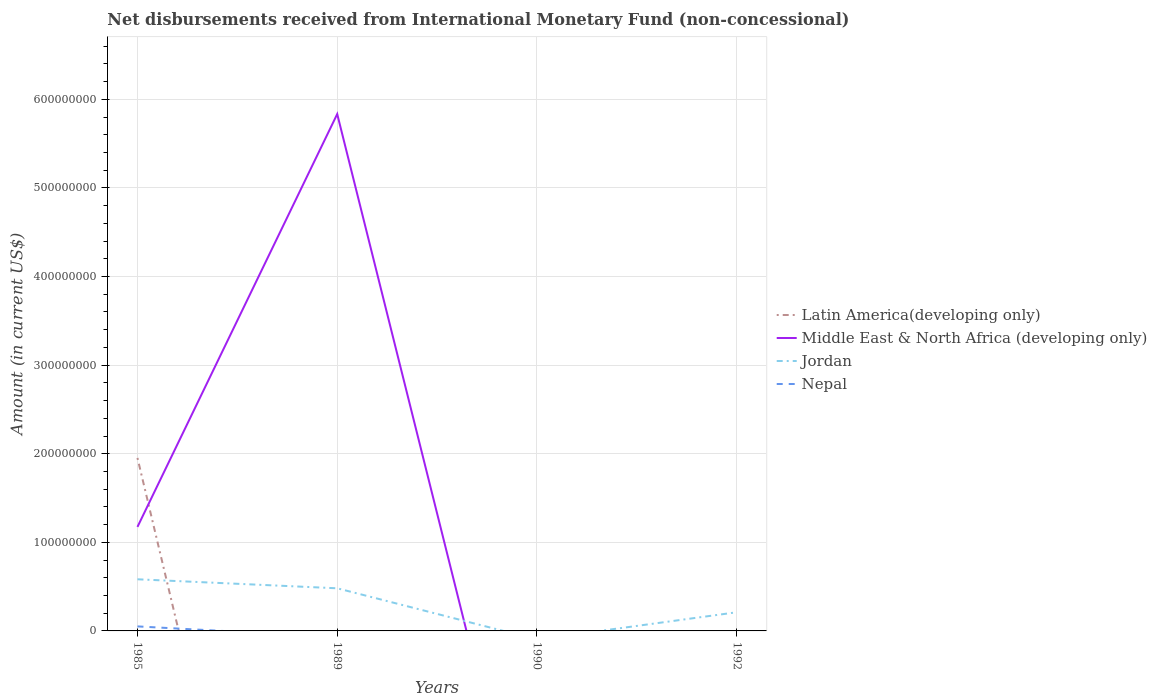How many different coloured lines are there?
Provide a succinct answer. 4. Does the line corresponding to Middle East & North Africa (developing only) intersect with the line corresponding to Jordan?
Keep it short and to the point. Yes. Across all years, what is the maximum amount of disbursements received from International Monetary Fund in Latin America(developing only)?
Give a very brief answer. 0. What is the total amount of disbursements received from International Monetary Fund in Middle East & North Africa (developing only) in the graph?
Provide a short and direct response. -4.66e+08. What is the difference between the highest and the second highest amount of disbursements received from International Monetary Fund in Jordan?
Your response must be concise. 5.83e+07. What is the difference between the highest and the lowest amount of disbursements received from International Monetary Fund in Middle East & North Africa (developing only)?
Your answer should be very brief. 1. What is the difference between two consecutive major ticks on the Y-axis?
Ensure brevity in your answer.  1.00e+08. Where does the legend appear in the graph?
Make the answer very short. Center right. How many legend labels are there?
Provide a short and direct response. 4. What is the title of the graph?
Give a very brief answer. Net disbursements received from International Monetary Fund (non-concessional). What is the label or title of the Y-axis?
Give a very brief answer. Amount (in current US$). What is the Amount (in current US$) of Latin America(developing only) in 1985?
Provide a succinct answer. 1.95e+08. What is the Amount (in current US$) of Middle East & North Africa (developing only) in 1985?
Provide a short and direct response. 1.17e+08. What is the Amount (in current US$) of Jordan in 1985?
Ensure brevity in your answer.  5.83e+07. What is the Amount (in current US$) of Nepal in 1985?
Give a very brief answer. 5.10e+06. What is the Amount (in current US$) of Latin America(developing only) in 1989?
Your answer should be compact. 0. What is the Amount (in current US$) of Middle East & North Africa (developing only) in 1989?
Give a very brief answer. 5.83e+08. What is the Amount (in current US$) of Jordan in 1989?
Your answer should be very brief. 4.81e+07. What is the Amount (in current US$) in Middle East & North Africa (developing only) in 1990?
Your response must be concise. 0. What is the Amount (in current US$) of Jordan in 1990?
Your answer should be compact. 0. What is the Amount (in current US$) of Nepal in 1990?
Keep it short and to the point. 0. What is the Amount (in current US$) in Latin America(developing only) in 1992?
Provide a short and direct response. 0. What is the Amount (in current US$) in Jordan in 1992?
Your answer should be very brief. 2.11e+07. Across all years, what is the maximum Amount (in current US$) of Latin America(developing only)?
Your response must be concise. 1.95e+08. Across all years, what is the maximum Amount (in current US$) in Middle East & North Africa (developing only)?
Your answer should be very brief. 5.83e+08. Across all years, what is the maximum Amount (in current US$) in Jordan?
Offer a terse response. 5.83e+07. Across all years, what is the maximum Amount (in current US$) of Nepal?
Offer a terse response. 5.10e+06. Across all years, what is the minimum Amount (in current US$) of Latin America(developing only)?
Your answer should be compact. 0. Across all years, what is the minimum Amount (in current US$) in Jordan?
Provide a succinct answer. 0. Across all years, what is the minimum Amount (in current US$) in Nepal?
Ensure brevity in your answer.  0. What is the total Amount (in current US$) in Latin America(developing only) in the graph?
Your answer should be compact. 1.95e+08. What is the total Amount (in current US$) in Middle East & North Africa (developing only) in the graph?
Keep it short and to the point. 7.01e+08. What is the total Amount (in current US$) of Jordan in the graph?
Keep it short and to the point. 1.27e+08. What is the total Amount (in current US$) in Nepal in the graph?
Your response must be concise. 5.10e+06. What is the difference between the Amount (in current US$) in Middle East & North Africa (developing only) in 1985 and that in 1989?
Make the answer very short. -4.66e+08. What is the difference between the Amount (in current US$) of Jordan in 1985 and that in 1989?
Your response must be concise. 1.02e+07. What is the difference between the Amount (in current US$) of Jordan in 1985 and that in 1992?
Keep it short and to the point. 3.72e+07. What is the difference between the Amount (in current US$) in Jordan in 1989 and that in 1992?
Offer a very short reply. 2.70e+07. What is the difference between the Amount (in current US$) in Latin America(developing only) in 1985 and the Amount (in current US$) in Middle East & North Africa (developing only) in 1989?
Give a very brief answer. -3.88e+08. What is the difference between the Amount (in current US$) of Latin America(developing only) in 1985 and the Amount (in current US$) of Jordan in 1989?
Your response must be concise. 1.47e+08. What is the difference between the Amount (in current US$) in Middle East & North Africa (developing only) in 1985 and the Amount (in current US$) in Jordan in 1989?
Offer a terse response. 6.93e+07. What is the difference between the Amount (in current US$) in Latin America(developing only) in 1985 and the Amount (in current US$) in Jordan in 1992?
Provide a succinct answer. 1.74e+08. What is the difference between the Amount (in current US$) in Middle East & North Africa (developing only) in 1985 and the Amount (in current US$) in Jordan in 1992?
Your answer should be compact. 9.63e+07. What is the difference between the Amount (in current US$) of Middle East & North Africa (developing only) in 1989 and the Amount (in current US$) of Jordan in 1992?
Your response must be concise. 5.62e+08. What is the average Amount (in current US$) of Latin America(developing only) per year?
Provide a short and direct response. 4.88e+07. What is the average Amount (in current US$) in Middle East & North Africa (developing only) per year?
Offer a terse response. 1.75e+08. What is the average Amount (in current US$) in Jordan per year?
Your answer should be compact. 3.19e+07. What is the average Amount (in current US$) in Nepal per year?
Your answer should be very brief. 1.28e+06. In the year 1985, what is the difference between the Amount (in current US$) of Latin America(developing only) and Amount (in current US$) of Middle East & North Africa (developing only)?
Provide a short and direct response. 7.79e+07. In the year 1985, what is the difference between the Amount (in current US$) in Latin America(developing only) and Amount (in current US$) in Jordan?
Your answer should be very brief. 1.37e+08. In the year 1985, what is the difference between the Amount (in current US$) of Latin America(developing only) and Amount (in current US$) of Nepal?
Give a very brief answer. 1.90e+08. In the year 1985, what is the difference between the Amount (in current US$) of Middle East & North Africa (developing only) and Amount (in current US$) of Jordan?
Provide a succinct answer. 5.91e+07. In the year 1985, what is the difference between the Amount (in current US$) of Middle East & North Africa (developing only) and Amount (in current US$) of Nepal?
Provide a succinct answer. 1.12e+08. In the year 1985, what is the difference between the Amount (in current US$) of Jordan and Amount (in current US$) of Nepal?
Keep it short and to the point. 5.32e+07. In the year 1989, what is the difference between the Amount (in current US$) in Middle East & North Africa (developing only) and Amount (in current US$) in Jordan?
Offer a very short reply. 5.35e+08. What is the ratio of the Amount (in current US$) in Middle East & North Africa (developing only) in 1985 to that in 1989?
Your answer should be very brief. 0.2. What is the ratio of the Amount (in current US$) in Jordan in 1985 to that in 1989?
Your answer should be very brief. 1.21. What is the ratio of the Amount (in current US$) of Jordan in 1985 to that in 1992?
Ensure brevity in your answer.  2.77. What is the ratio of the Amount (in current US$) of Jordan in 1989 to that in 1992?
Your answer should be very brief. 2.28. What is the difference between the highest and the second highest Amount (in current US$) in Jordan?
Provide a short and direct response. 1.02e+07. What is the difference between the highest and the lowest Amount (in current US$) in Latin America(developing only)?
Give a very brief answer. 1.95e+08. What is the difference between the highest and the lowest Amount (in current US$) of Middle East & North Africa (developing only)?
Make the answer very short. 5.83e+08. What is the difference between the highest and the lowest Amount (in current US$) in Jordan?
Ensure brevity in your answer.  5.83e+07. What is the difference between the highest and the lowest Amount (in current US$) of Nepal?
Keep it short and to the point. 5.10e+06. 